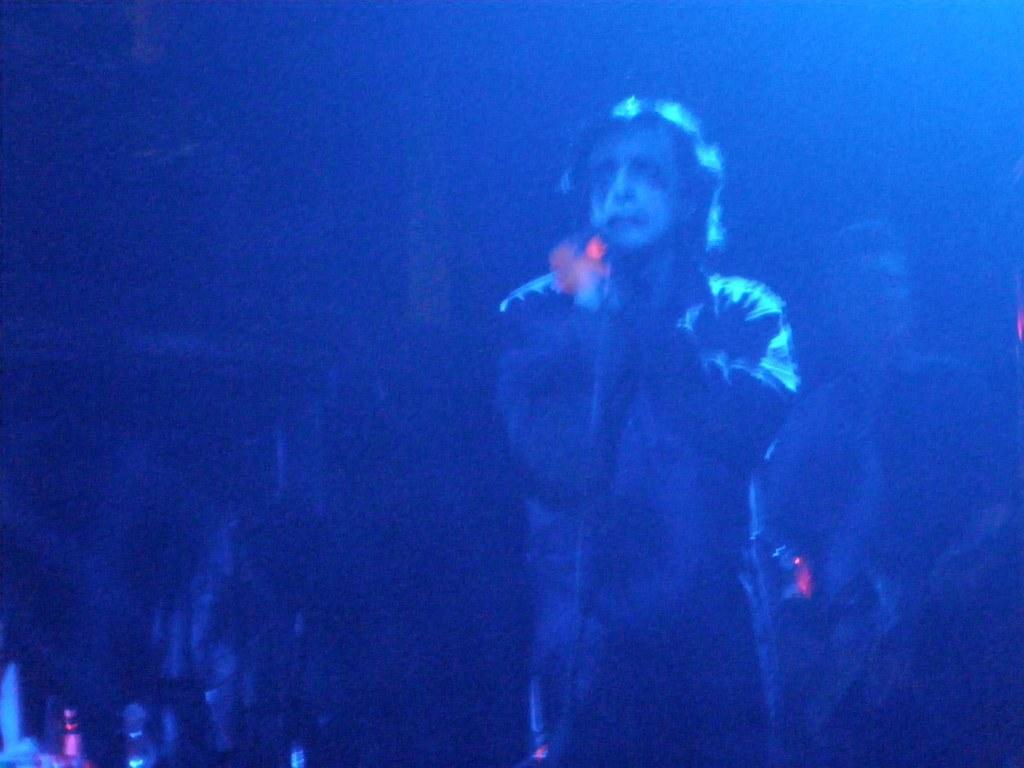How would you summarize this image in a sentence or two? This is an image clicked in the dark. On the right side, I can see two persons are standing. This image is in blue color. 